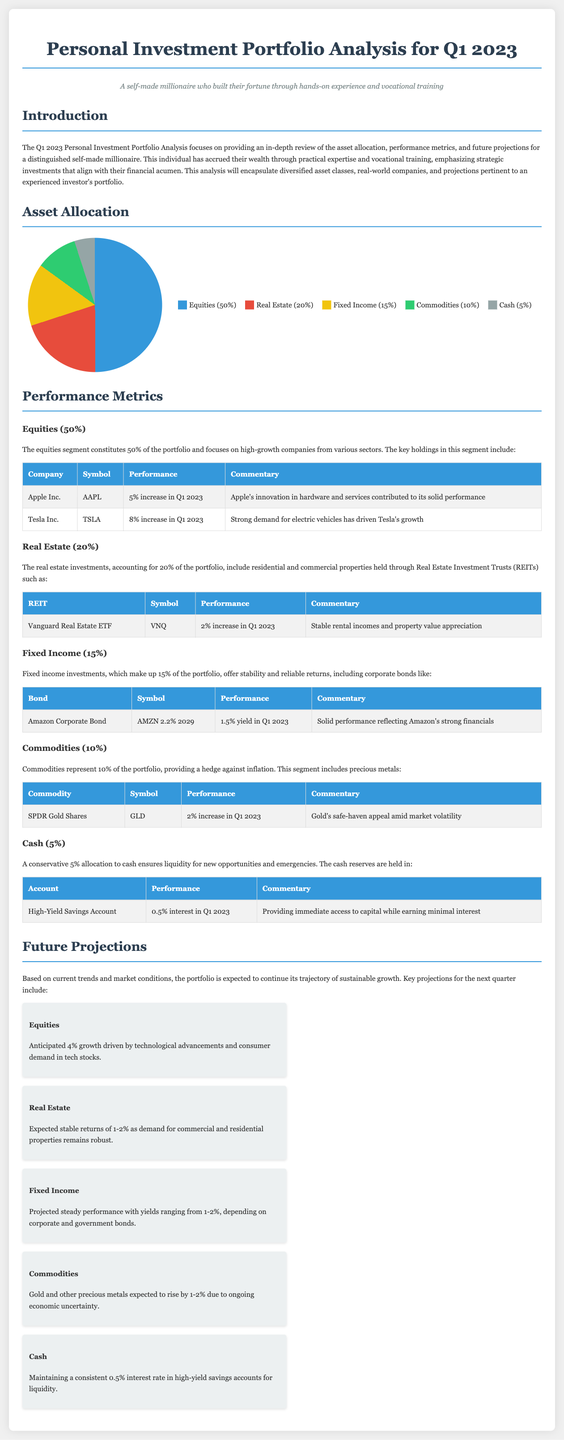What percentage of the portfolio is allocated to Equities? The document states that Equities make up 50% of the portfolio.
Answer: 50% What is the performance increase for Tesla Inc. in Q1 2023? The document indicates that Tesla Inc. had an 8% increase in Q1 2023.
Answer: 8% What is the anticipated growth for the Equities segment in the next quarter? The document mentions an anticipated 4% growth driven by technological advancements.
Answer: 4% Which REIT is mentioned in the Real Estate section? The document lists the Vanguard Real Estate ETF as the REIT in the Real Estate section.
Answer: Vanguard Real Estate ETF What percentage of the portfolio is allocated to Cash? The document specifies that Cash comprises 5% of the portfolio.
Answer: 5% What performance increase did SPDR Gold Shares experience in Q1 2023? The document states that SPDR Gold Shares had a 2% increase in Q1 2023.
Answer: 2% How much yield did the Amazon Corporate Bond generate in Q1 2023? The document indicates the Amazon Corporate Bond had a 1.5% yield in Q1 2023.
Answer: 1.5% What is the interest rate for the high-yield savings account mentioned? The document specifies that the high-yield savings account has a 0.5% interest rate.
Answer: 0.5% What future projection is made for Commodities in the next quarter? The document projects that Commodities will rise by 1-2% due to ongoing economic uncertainty.
Answer: 1-2% 